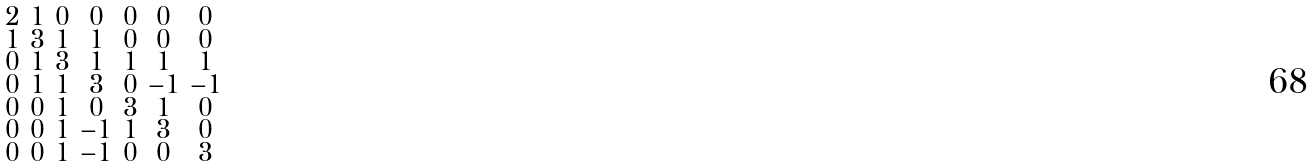<formula> <loc_0><loc_0><loc_500><loc_500>\begin{smallmatrix} 2 & 1 & 0 & 0 & 0 & 0 & 0 \\ 1 & 3 & 1 & 1 & 0 & 0 & 0 \\ 0 & 1 & 3 & 1 & 1 & 1 & 1 \\ 0 & 1 & 1 & 3 & 0 & - 1 & - 1 \\ 0 & 0 & 1 & 0 & 3 & 1 & 0 \\ 0 & 0 & 1 & - 1 & 1 & 3 & 0 \\ 0 & 0 & 1 & - 1 & 0 & 0 & 3 \end{smallmatrix}</formula> 